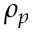Convert formula to latex. <formula><loc_0><loc_0><loc_500><loc_500>\rho _ { p }</formula> 